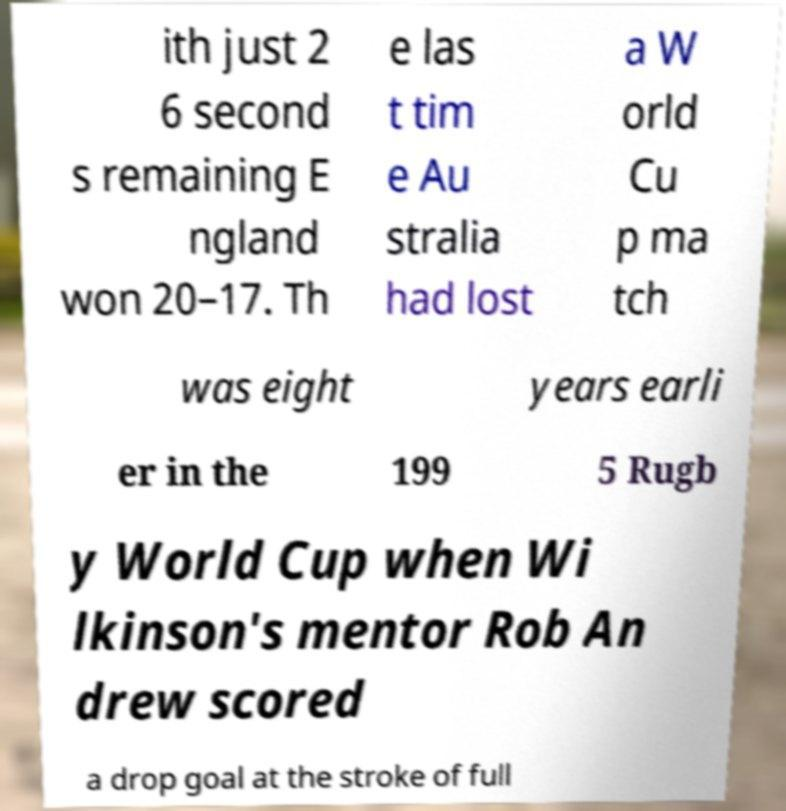I need the written content from this picture converted into text. Can you do that? ith just 2 6 second s remaining E ngland won 20–17. Th e las t tim e Au stralia had lost a W orld Cu p ma tch was eight years earli er in the 199 5 Rugb y World Cup when Wi lkinson's mentor Rob An drew scored a drop goal at the stroke of full 